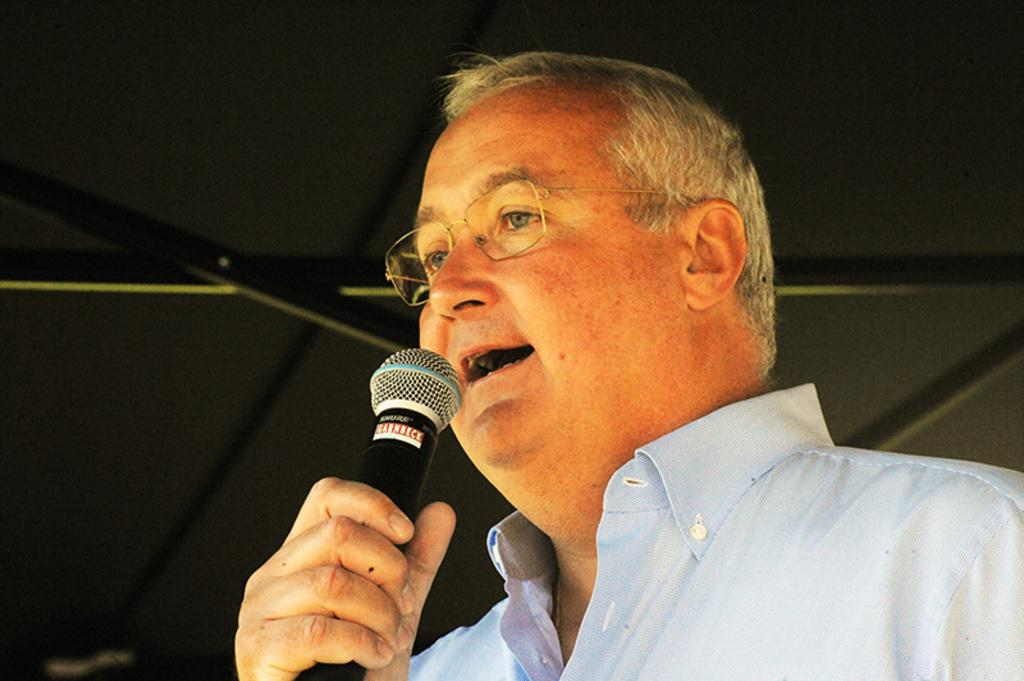Who is the main subject in the image? There is a man in the image. What is the man doing in the image? The man is talking on a microphone. Can you describe the man's appearance? The man is wearing spectacles. What is the color of the background in the image? The background of the image is black. What type of soup is being served in the image? There is no soup present in the image. Can you describe the roof of the building in the image? There is no roof visible in the image, as it is focused on the man talking on a microphone. 